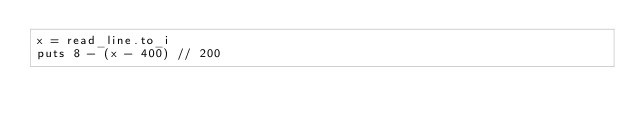<code> <loc_0><loc_0><loc_500><loc_500><_Crystal_>x = read_line.to_i
puts 8 - (x - 400) // 200
</code> 